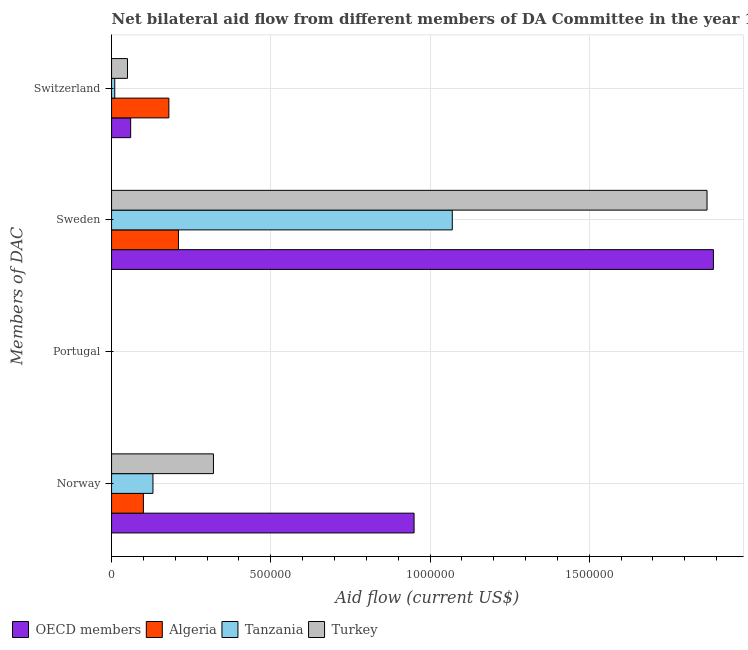Are the number of bars per tick equal to the number of legend labels?
Offer a terse response. No. Are the number of bars on each tick of the Y-axis equal?
Make the answer very short. No. What is the amount of aid given by norway in Tanzania?
Your answer should be compact. 1.30e+05. Across all countries, what is the maximum amount of aid given by norway?
Keep it short and to the point. 9.50e+05. In which country was the amount of aid given by switzerland maximum?
Keep it short and to the point. Algeria. What is the total amount of aid given by portugal in the graph?
Make the answer very short. 0. What is the difference between the amount of aid given by sweden in OECD members and that in Algeria?
Provide a succinct answer. 1.68e+06. What is the average amount of aid given by norway per country?
Offer a very short reply. 3.75e+05. What is the difference between the amount of aid given by sweden and amount of aid given by switzerland in Turkey?
Your response must be concise. 1.82e+06. In how many countries, is the amount of aid given by norway greater than 800000 US$?
Ensure brevity in your answer.  1. Is the difference between the amount of aid given by sweden in Algeria and OECD members greater than the difference between the amount of aid given by norway in Algeria and OECD members?
Provide a succinct answer. No. What is the difference between the highest and the second highest amount of aid given by switzerland?
Offer a very short reply. 1.20e+05. In how many countries, is the amount of aid given by switzerland greater than the average amount of aid given by switzerland taken over all countries?
Provide a succinct answer. 1. Is the sum of the amount of aid given by switzerland in Algeria and Tanzania greater than the maximum amount of aid given by portugal across all countries?
Ensure brevity in your answer.  Yes. Is it the case that in every country, the sum of the amount of aid given by sweden and amount of aid given by switzerland is greater than the sum of amount of aid given by norway and amount of aid given by portugal?
Give a very brief answer. No. Is it the case that in every country, the sum of the amount of aid given by norway and amount of aid given by portugal is greater than the amount of aid given by sweden?
Provide a short and direct response. No. How many countries are there in the graph?
Provide a succinct answer. 4. Are the values on the major ticks of X-axis written in scientific E-notation?
Provide a short and direct response. No. Does the graph contain any zero values?
Make the answer very short. Yes. Does the graph contain grids?
Ensure brevity in your answer.  Yes. Where does the legend appear in the graph?
Give a very brief answer. Bottom left. What is the title of the graph?
Offer a terse response. Net bilateral aid flow from different members of DA Committee in the year 1964. Does "Netherlands" appear as one of the legend labels in the graph?
Your answer should be very brief. No. What is the label or title of the X-axis?
Provide a short and direct response. Aid flow (current US$). What is the label or title of the Y-axis?
Offer a very short reply. Members of DAC. What is the Aid flow (current US$) of OECD members in Norway?
Provide a short and direct response. 9.50e+05. What is the Aid flow (current US$) of Tanzania in Norway?
Keep it short and to the point. 1.30e+05. What is the Aid flow (current US$) in Turkey in Norway?
Your answer should be compact. 3.20e+05. What is the Aid flow (current US$) in OECD members in Portugal?
Provide a succinct answer. Nan. What is the Aid flow (current US$) of Algeria in Portugal?
Provide a succinct answer. Nan. What is the Aid flow (current US$) in Tanzania in Portugal?
Your answer should be compact. Nan. What is the Aid flow (current US$) of Turkey in Portugal?
Offer a very short reply. Nan. What is the Aid flow (current US$) of OECD members in Sweden?
Ensure brevity in your answer.  1.89e+06. What is the Aid flow (current US$) in Algeria in Sweden?
Make the answer very short. 2.10e+05. What is the Aid flow (current US$) of Tanzania in Sweden?
Provide a short and direct response. 1.07e+06. What is the Aid flow (current US$) of Turkey in Sweden?
Make the answer very short. 1.87e+06. What is the Aid flow (current US$) in OECD members in Switzerland?
Keep it short and to the point. 6.00e+04. What is the Aid flow (current US$) in Turkey in Switzerland?
Ensure brevity in your answer.  5.00e+04. Across all Members of DAC, what is the maximum Aid flow (current US$) of OECD members?
Offer a very short reply. 1.89e+06. Across all Members of DAC, what is the maximum Aid flow (current US$) of Tanzania?
Offer a terse response. 1.07e+06. Across all Members of DAC, what is the maximum Aid flow (current US$) in Turkey?
Your response must be concise. 1.87e+06. Across all Members of DAC, what is the minimum Aid flow (current US$) of OECD members?
Provide a succinct answer. 6.00e+04. What is the total Aid flow (current US$) in OECD members in the graph?
Offer a very short reply. 2.90e+06. What is the total Aid flow (current US$) in Algeria in the graph?
Keep it short and to the point. 4.90e+05. What is the total Aid flow (current US$) in Tanzania in the graph?
Ensure brevity in your answer.  1.21e+06. What is the total Aid flow (current US$) in Turkey in the graph?
Offer a very short reply. 2.24e+06. What is the difference between the Aid flow (current US$) of OECD members in Norway and that in Portugal?
Offer a terse response. Nan. What is the difference between the Aid flow (current US$) of Algeria in Norway and that in Portugal?
Your answer should be very brief. Nan. What is the difference between the Aid flow (current US$) in Tanzania in Norway and that in Portugal?
Your answer should be compact. Nan. What is the difference between the Aid flow (current US$) of Turkey in Norway and that in Portugal?
Ensure brevity in your answer.  Nan. What is the difference between the Aid flow (current US$) in OECD members in Norway and that in Sweden?
Provide a short and direct response. -9.40e+05. What is the difference between the Aid flow (current US$) in Tanzania in Norway and that in Sweden?
Your response must be concise. -9.40e+05. What is the difference between the Aid flow (current US$) of Turkey in Norway and that in Sweden?
Ensure brevity in your answer.  -1.55e+06. What is the difference between the Aid flow (current US$) of OECD members in Norway and that in Switzerland?
Offer a very short reply. 8.90e+05. What is the difference between the Aid flow (current US$) of OECD members in Portugal and that in Sweden?
Offer a very short reply. Nan. What is the difference between the Aid flow (current US$) in Algeria in Portugal and that in Sweden?
Provide a succinct answer. Nan. What is the difference between the Aid flow (current US$) of Tanzania in Portugal and that in Sweden?
Provide a succinct answer. Nan. What is the difference between the Aid flow (current US$) in Turkey in Portugal and that in Sweden?
Your response must be concise. Nan. What is the difference between the Aid flow (current US$) of OECD members in Portugal and that in Switzerland?
Keep it short and to the point. Nan. What is the difference between the Aid flow (current US$) of Algeria in Portugal and that in Switzerland?
Your answer should be compact. Nan. What is the difference between the Aid flow (current US$) of Tanzania in Portugal and that in Switzerland?
Keep it short and to the point. Nan. What is the difference between the Aid flow (current US$) in Turkey in Portugal and that in Switzerland?
Provide a short and direct response. Nan. What is the difference between the Aid flow (current US$) of OECD members in Sweden and that in Switzerland?
Your answer should be compact. 1.83e+06. What is the difference between the Aid flow (current US$) of Tanzania in Sweden and that in Switzerland?
Provide a short and direct response. 1.06e+06. What is the difference between the Aid flow (current US$) of Turkey in Sweden and that in Switzerland?
Your answer should be compact. 1.82e+06. What is the difference between the Aid flow (current US$) of OECD members in Norway and the Aid flow (current US$) of Algeria in Portugal?
Offer a terse response. Nan. What is the difference between the Aid flow (current US$) of OECD members in Norway and the Aid flow (current US$) of Tanzania in Portugal?
Offer a terse response. Nan. What is the difference between the Aid flow (current US$) of OECD members in Norway and the Aid flow (current US$) of Turkey in Portugal?
Your answer should be very brief. Nan. What is the difference between the Aid flow (current US$) of Algeria in Norway and the Aid flow (current US$) of Tanzania in Portugal?
Offer a terse response. Nan. What is the difference between the Aid flow (current US$) in Algeria in Norway and the Aid flow (current US$) in Turkey in Portugal?
Your response must be concise. Nan. What is the difference between the Aid flow (current US$) in Tanzania in Norway and the Aid flow (current US$) in Turkey in Portugal?
Ensure brevity in your answer.  Nan. What is the difference between the Aid flow (current US$) in OECD members in Norway and the Aid flow (current US$) in Algeria in Sweden?
Your answer should be compact. 7.40e+05. What is the difference between the Aid flow (current US$) of OECD members in Norway and the Aid flow (current US$) of Turkey in Sweden?
Your answer should be compact. -9.20e+05. What is the difference between the Aid flow (current US$) in Algeria in Norway and the Aid flow (current US$) in Tanzania in Sweden?
Offer a very short reply. -9.70e+05. What is the difference between the Aid flow (current US$) in Algeria in Norway and the Aid flow (current US$) in Turkey in Sweden?
Offer a terse response. -1.77e+06. What is the difference between the Aid flow (current US$) of Tanzania in Norway and the Aid flow (current US$) of Turkey in Sweden?
Offer a terse response. -1.74e+06. What is the difference between the Aid flow (current US$) of OECD members in Norway and the Aid flow (current US$) of Algeria in Switzerland?
Your response must be concise. 7.70e+05. What is the difference between the Aid flow (current US$) of OECD members in Norway and the Aid flow (current US$) of Tanzania in Switzerland?
Offer a terse response. 9.40e+05. What is the difference between the Aid flow (current US$) in Algeria in Norway and the Aid flow (current US$) in Tanzania in Switzerland?
Offer a very short reply. 9.00e+04. What is the difference between the Aid flow (current US$) in Tanzania in Norway and the Aid flow (current US$) in Turkey in Switzerland?
Give a very brief answer. 8.00e+04. What is the difference between the Aid flow (current US$) in OECD members in Portugal and the Aid flow (current US$) in Algeria in Sweden?
Offer a terse response. Nan. What is the difference between the Aid flow (current US$) of OECD members in Portugal and the Aid flow (current US$) of Tanzania in Sweden?
Your answer should be compact. Nan. What is the difference between the Aid flow (current US$) in OECD members in Portugal and the Aid flow (current US$) in Turkey in Sweden?
Ensure brevity in your answer.  Nan. What is the difference between the Aid flow (current US$) of Algeria in Portugal and the Aid flow (current US$) of Tanzania in Sweden?
Give a very brief answer. Nan. What is the difference between the Aid flow (current US$) in Algeria in Portugal and the Aid flow (current US$) in Turkey in Sweden?
Provide a short and direct response. Nan. What is the difference between the Aid flow (current US$) in Tanzania in Portugal and the Aid flow (current US$) in Turkey in Sweden?
Provide a succinct answer. Nan. What is the difference between the Aid flow (current US$) in OECD members in Portugal and the Aid flow (current US$) in Algeria in Switzerland?
Offer a terse response. Nan. What is the difference between the Aid flow (current US$) of OECD members in Portugal and the Aid flow (current US$) of Tanzania in Switzerland?
Make the answer very short. Nan. What is the difference between the Aid flow (current US$) of OECD members in Portugal and the Aid flow (current US$) of Turkey in Switzerland?
Offer a very short reply. Nan. What is the difference between the Aid flow (current US$) in Algeria in Portugal and the Aid flow (current US$) in Tanzania in Switzerland?
Provide a short and direct response. Nan. What is the difference between the Aid flow (current US$) in Algeria in Portugal and the Aid flow (current US$) in Turkey in Switzerland?
Ensure brevity in your answer.  Nan. What is the difference between the Aid flow (current US$) of Tanzania in Portugal and the Aid flow (current US$) of Turkey in Switzerland?
Keep it short and to the point. Nan. What is the difference between the Aid flow (current US$) of OECD members in Sweden and the Aid flow (current US$) of Algeria in Switzerland?
Your answer should be compact. 1.71e+06. What is the difference between the Aid flow (current US$) in OECD members in Sweden and the Aid flow (current US$) in Tanzania in Switzerland?
Provide a succinct answer. 1.88e+06. What is the difference between the Aid flow (current US$) in OECD members in Sweden and the Aid flow (current US$) in Turkey in Switzerland?
Your response must be concise. 1.84e+06. What is the difference between the Aid flow (current US$) of Tanzania in Sweden and the Aid flow (current US$) of Turkey in Switzerland?
Your answer should be very brief. 1.02e+06. What is the average Aid flow (current US$) of OECD members per Members of DAC?
Keep it short and to the point. 7.25e+05. What is the average Aid flow (current US$) in Algeria per Members of DAC?
Provide a succinct answer. 1.22e+05. What is the average Aid flow (current US$) in Tanzania per Members of DAC?
Ensure brevity in your answer.  3.02e+05. What is the average Aid flow (current US$) in Turkey per Members of DAC?
Give a very brief answer. 5.60e+05. What is the difference between the Aid flow (current US$) of OECD members and Aid flow (current US$) of Algeria in Norway?
Offer a very short reply. 8.50e+05. What is the difference between the Aid flow (current US$) of OECD members and Aid flow (current US$) of Tanzania in Norway?
Keep it short and to the point. 8.20e+05. What is the difference between the Aid flow (current US$) of OECD members and Aid flow (current US$) of Turkey in Norway?
Provide a short and direct response. 6.30e+05. What is the difference between the Aid flow (current US$) in OECD members and Aid flow (current US$) in Algeria in Portugal?
Ensure brevity in your answer.  Nan. What is the difference between the Aid flow (current US$) of OECD members and Aid flow (current US$) of Tanzania in Portugal?
Your response must be concise. Nan. What is the difference between the Aid flow (current US$) in OECD members and Aid flow (current US$) in Turkey in Portugal?
Your answer should be compact. Nan. What is the difference between the Aid flow (current US$) in Algeria and Aid flow (current US$) in Tanzania in Portugal?
Ensure brevity in your answer.  Nan. What is the difference between the Aid flow (current US$) in Algeria and Aid flow (current US$) in Turkey in Portugal?
Your response must be concise. Nan. What is the difference between the Aid flow (current US$) of Tanzania and Aid flow (current US$) of Turkey in Portugal?
Keep it short and to the point. Nan. What is the difference between the Aid flow (current US$) of OECD members and Aid flow (current US$) of Algeria in Sweden?
Your answer should be very brief. 1.68e+06. What is the difference between the Aid flow (current US$) of OECD members and Aid flow (current US$) of Tanzania in Sweden?
Make the answer very short. 8.20e+05. What is the difference between the Aid flow (current US$) in Algeria and Aid flow (current US$) in Tanzania in Sweden?
Offer a terse response. -8.60e+05. What is the difference between the Aid flow (current US$) of Algeria and Aid flow (current US$) of Turkey in Sweden?
Make the answer very short. -1.66e+06. What is the difference between the Aid flow (current US$) of Tanzania and Aid flow (current US$) of Turkey in Sweden?
Offer a very short reply. -8.00e+05. What is the difference between the Aid flow (current US$) in OECD members and Aid flow (current US$) in Algeria in Switzerland?
Give a very brief answer. -1.20e+05. What is the difference between the Aid flow (current US$) in OECD members and Aid flow (current US$) in Tanzania in Switzerland?
Offer a very short reply. 5.00e+04. What is the difference between the Aid flow (current US$) of OECD members and Aid flow (current US$) of Turkey in Switzerland?
Your response must be concise. 10000. What is the ratio of the Aid flow (current US$) in OECD members in Norway to that in Portugal?
Provide a short and direct response. Nan. What is the ratio of the Aid flow (current US$) in Algeria in Norway to that in Portugal?
Keep it short and to the point. Nan. What is the ratio of the Aid flow (current US$) in Tanzania in Norway to that in Portugal?
Provide a short and direct response. Nan. What is the ratio of the Aid flow (current US$) in Turkey in Norway to that in Portugal?
Give a very brief answer. Nan. What is the ratio of the Aid flow (current US$) in OECD members in Norway to that in Sweden?
Keep it short and to the point. 0.5. What is the ratio of the Aid flow (current US$) of Algeria in Norway to that in Sweden?
Offer a very short reply. 0.48. What is the ratio of the Aid flow (current US$) in Tanzania in Norway to that in Sweden?
Your response must be concise. 0.12. What is the ratio of the Aid flow (current US$) in Turkey in Norway to that in Sweden?
Your answer should be very brief. 0.17. What is the ratio of the Aid flow (current US$) in OECD members in Norway to that in Switzerland?
Keep it short and to the point. 15.83. What is the ratio of the Aid flow (current US$) of Algeria in Norway to that in Switzerland?
Your answer should be very brief. 0.56. What is the ratio of the Aid flow (current US$) of Turkey in Norway to that in Switzerland?
Your answer should be very brief. 6.4. What is the ratio of the Aid flow (current US$) of OECD members in Portugal to that in Sweden?
Your response must be concise. Nan. What is the ratio of the Aid flow (current US$) in Algeria in Portugal to that in Sweden?
Provide a succinct answer. Nan. What is the ratio of the Aid flow (current US$) of Tanzania in Portugal to that in Sweden?
Make the answer very short. Nan. What is the ratio of the Aid flow (current US$) in Turkey in Portugal to that in Sweden?
Your response must be concise. Nan. What is the ratio of the Aid flow (current US$) of OECD members in Portugal to that in Switzerland?
Keep it short and to the point. Nan. What is the ratio of the Aid flow (current US$) of Algeria in Portugal to that in Switzerland?
Keep it short and to the point. Nan. What is the ratio of the Aid flow (current US$) of Tanzania in Portugal to that in Switzerland?
Give a very brief answer. Nan. What is the ratio of the Aid flow (current US$) in Turkey in Portugal to that in Switzerland?
Ensure brevity in your answer.  Nan. What is the ratio of the Aid flow (current US$) of OECD members in Sweden to that in Switzerland?
Provide a succinct answer. 31.5. What is the ratio of the Aid flow (current US$) in Algeria in Sweden to that in Switzerland?
Offer a terse response. 1.17. What is the ratio of the Aid flow (current US$) in Tanzania in Sweden to that in Switzerland?
Provide a short and direct response. 107. What is the ratio of the Aid flow (current US$) in Turkey in Sweden to that in Switzerland?
Give a very brief answer. 37.4. What is the difference between the highest and the second highest Aid flow (current US$) in OECD members?
Your answer should be very brief. 9.40e+05. What is the difference between the highest and the second highest Aid flow (current US$) of Algeria?
Offer a very short reply. 3.00e+04. What is the difference between the highest and the second highest Aid flow (current US$) in Tanzania?
Provide a succinct answer. 9.40e+05. What is the difference between the highest and the second highest Aid flow (current US$) of Turkey?
Make the answer very short. 1.55e+06. What is the difference between the highest and the lowest Aid flow (current US$) in OECD members?
Your response must be concise. 1.83e+06. What is the difference between the highest and the lowest Aid flow (current US$) in Algeria?
Your answer should be compact. 1.10e+05. What is the difference between the highest and the lowest Aid flow (current US$) of Tanzania?
Offer a terse response. 1.06e+06. What is the difference between the highest and the lowest Aid flow (current US$) in Turkey?
Give a very brief answer. 1.82e+06. 